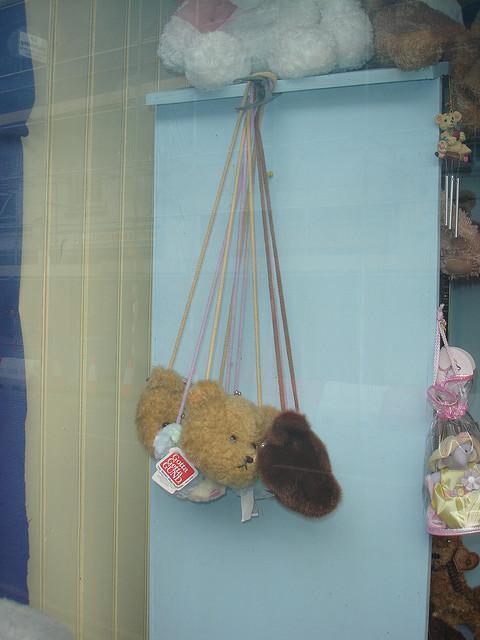How many teddy bears can you see?
Give a very brief answer. 4. 